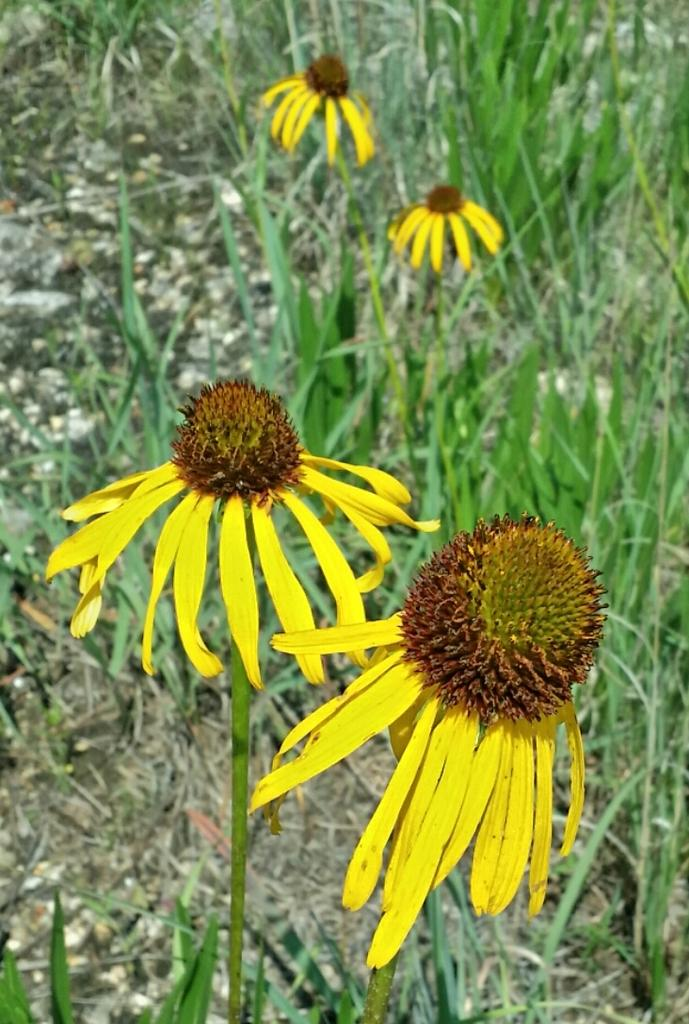What type of living organisms can be seen in the image? There are flowers and plants in the image. Can you describe the plants in the image? The plants in the image are not specified, but they are present alongside the flowers. What type of car can be seen in the image? There is no car present in the image; it only features flowers and plants. What type of flesh is visible in the image? There is no flesh visible in the image; it only features flowers and plants. 